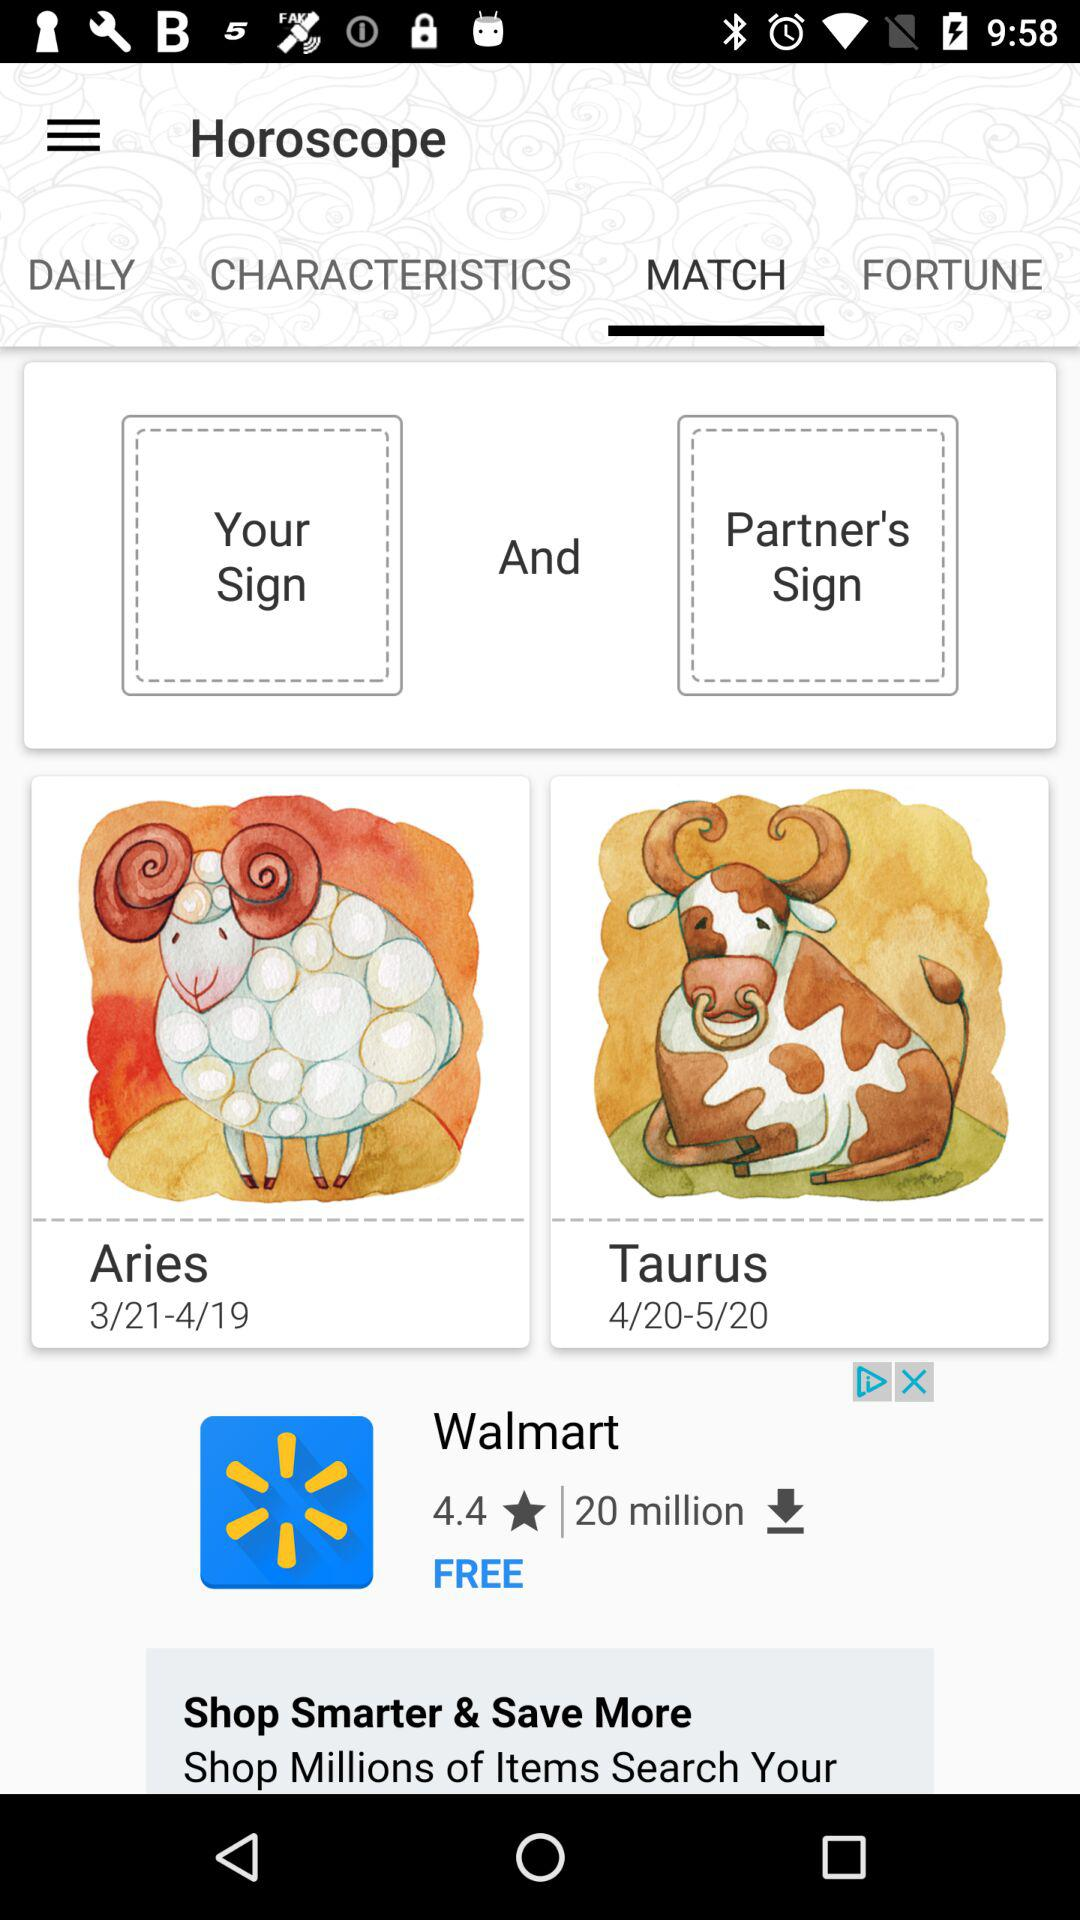Which tab is open? The open tab is "MATCH". 